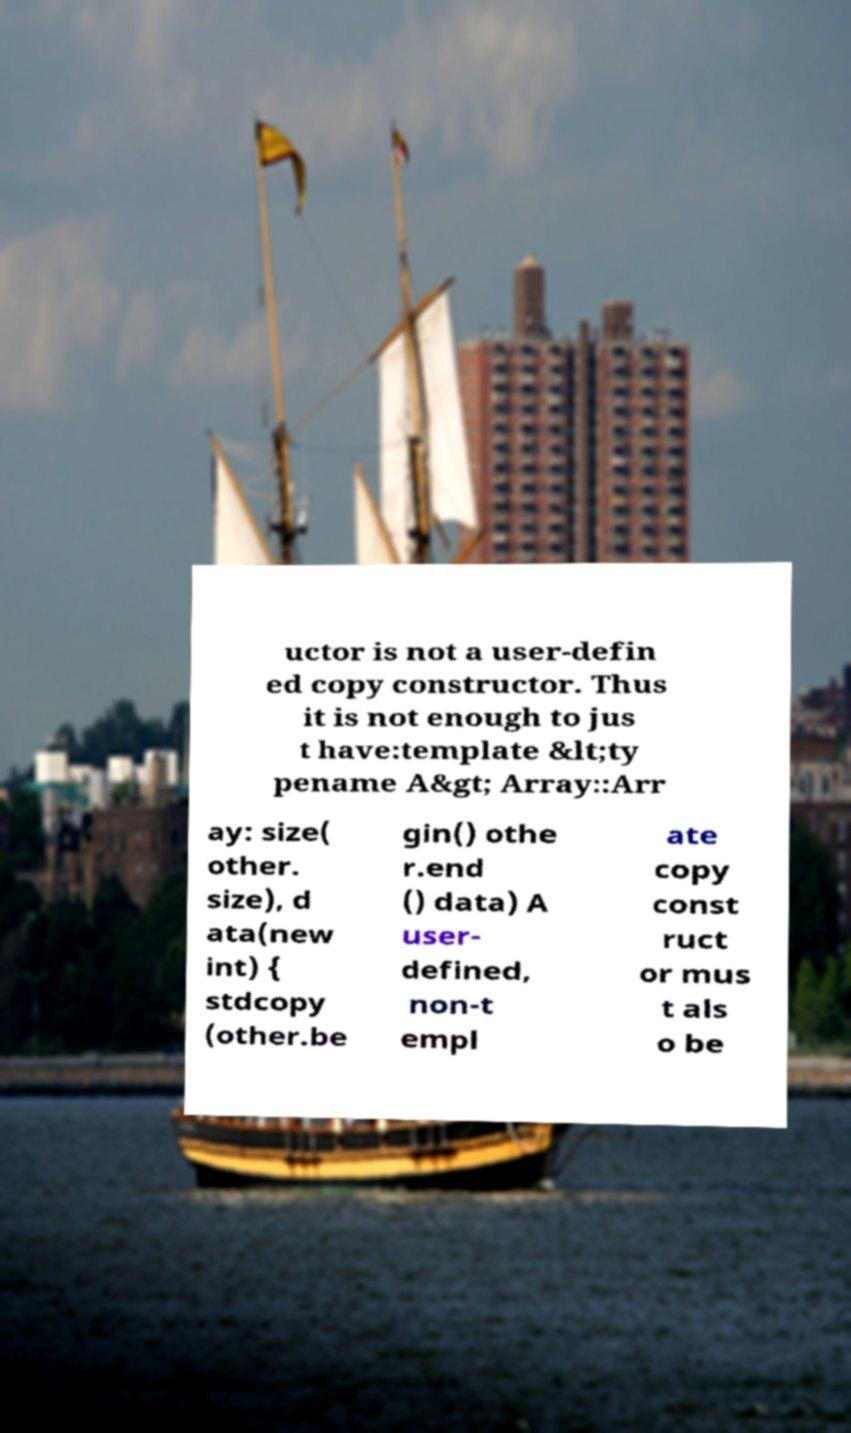Can you read and provide the text displayed in the image?This photo seems to have some interesting text. Can you extract and type it out for me? uctor is not a user-defin ed copy constructor. Thus it is not enough to jus t have:template &lt;ty pename A&gt; Array::Arr ay: size( other. size), d ata(new int) { stdcopy (other.be gin() othe r.end () data) A user- defined, non-t empl ate copy const ruct or mus t als o be 